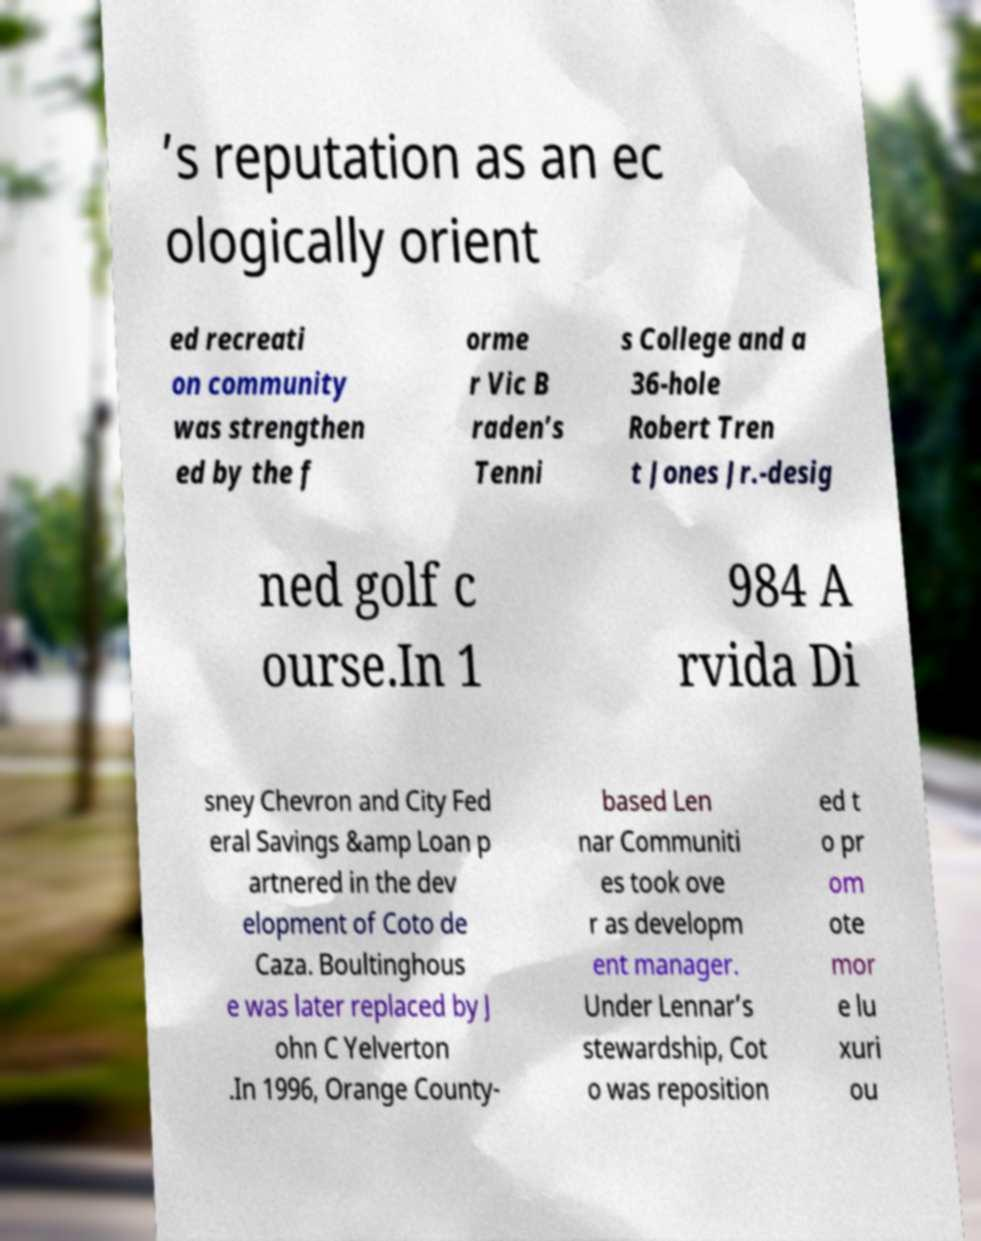There's text embedded in this image that I need extracted. Can you transcribe it verbatim? ’s reputation as an ec ologically orient ed recreati on community was strengthen ed by the f orme r Vic B raden’s Tenni s College and a 36-hole Robert Tren t Jones Jr.-desig ned golf c ourse.In 1 984 A rvida Di sney Chevron and City Fed eral Savings &amp Loan p artnered in the dev elopment of Coto de Caza. Boultinghous e was later replaced by J ohn C Yelverton .In 1996, Orange County- based Len nar Communiti es took ove r as developm ent manager. Under Lennar’s stewardship, Cot o was reposition ed t o pr om ote mor e lu xuri ou 